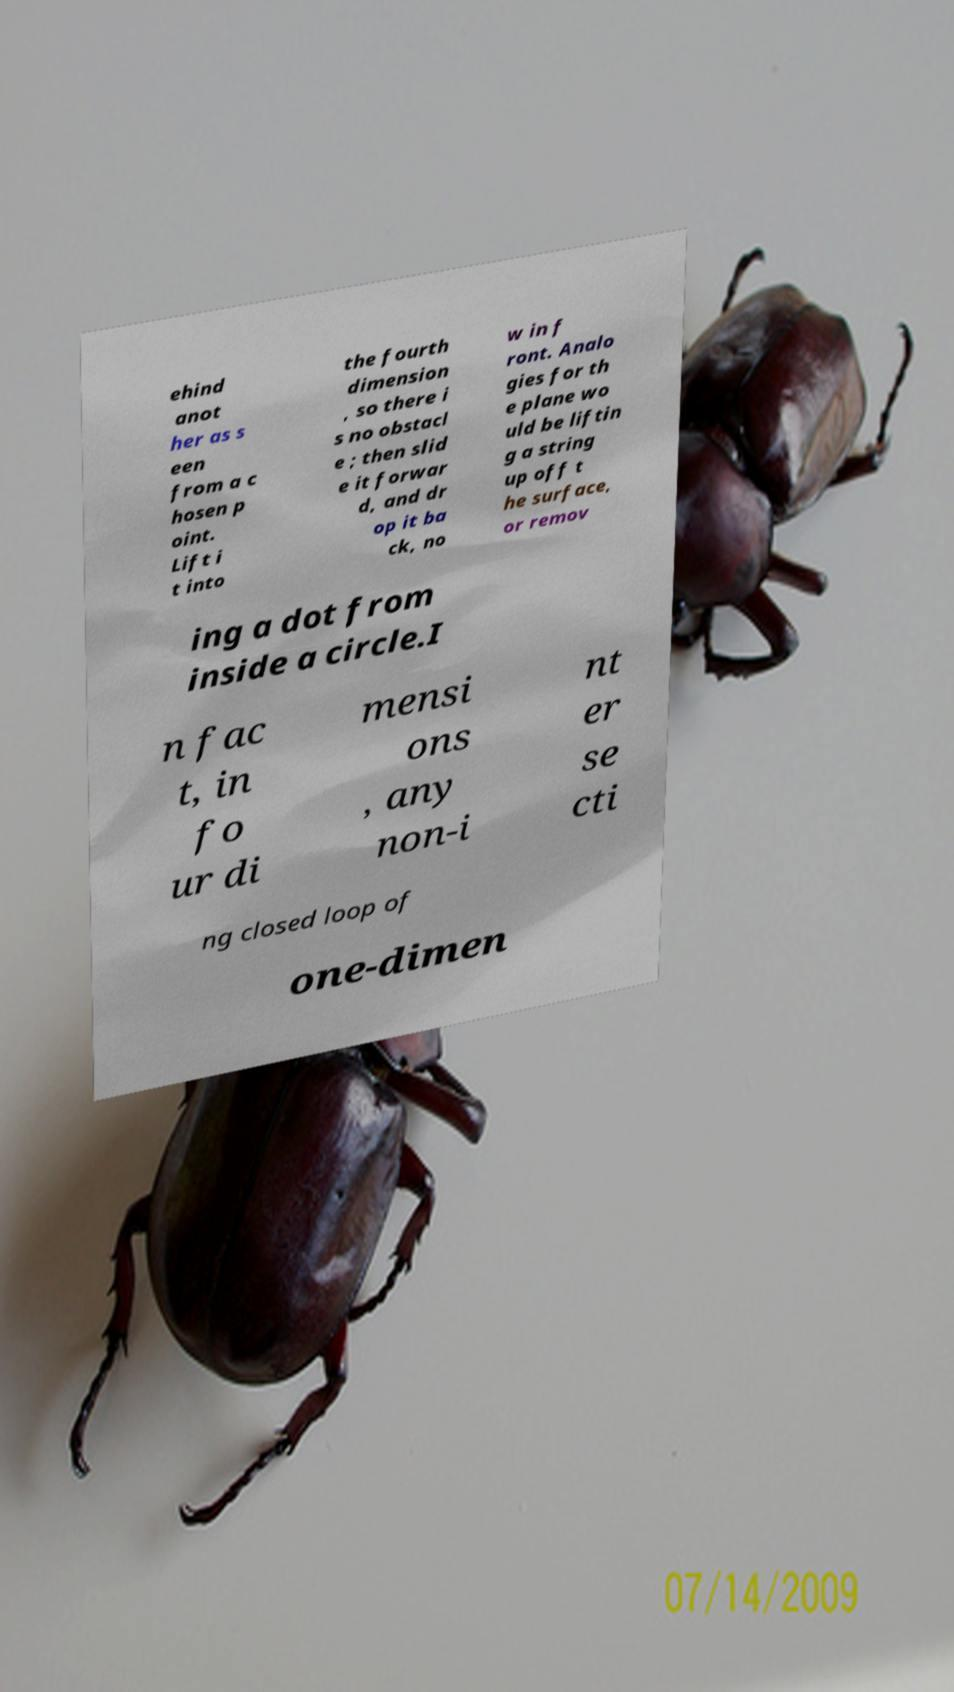Could you assist in decoding the text presented in this image and type it out clearly? ehind anot her as s een from a c hosen p oint. Lift i t into the fourth dimension , so there i s no obstacl e ; then slid e it forwar d, and dr op it ba ck, no w in f ront. Analo gies for th e plane wo uld be liftin g a string up off t he surface, or remov ing a dot from inside a circle.I n fac t, in fo ur di mensi ons , any non-i nt er se cti ng closed loop of one-dimen 